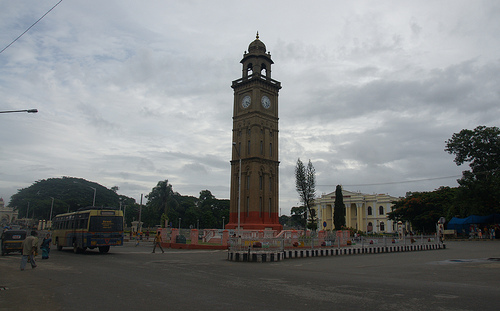How many palm trees are in the picture? 0 